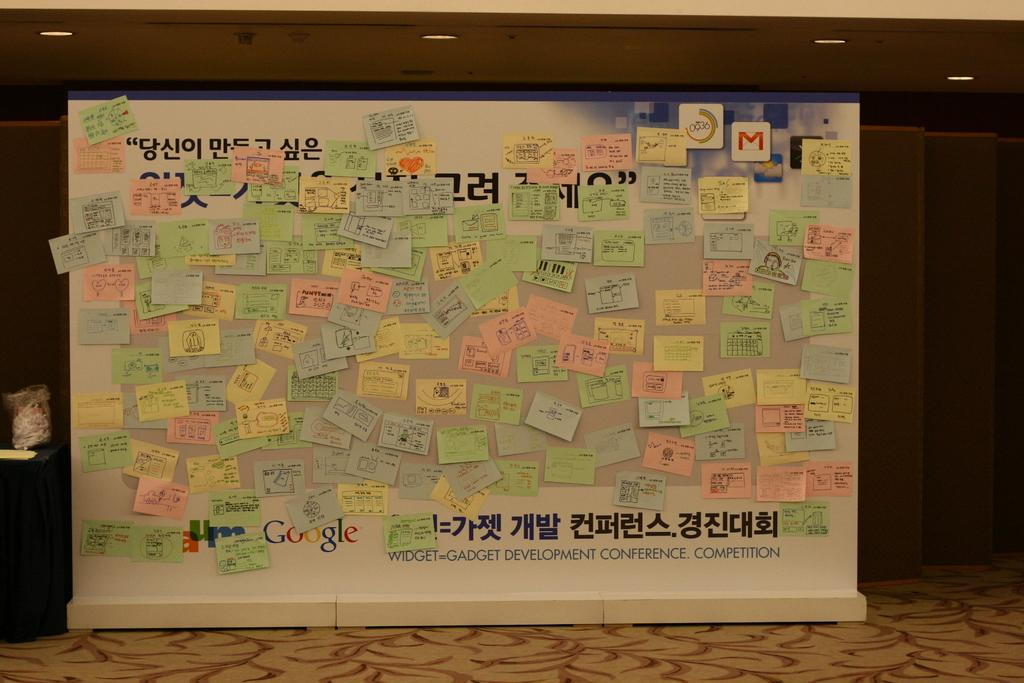<image>
Describe the image concisely. A board from Google is covered with post-it notes. 